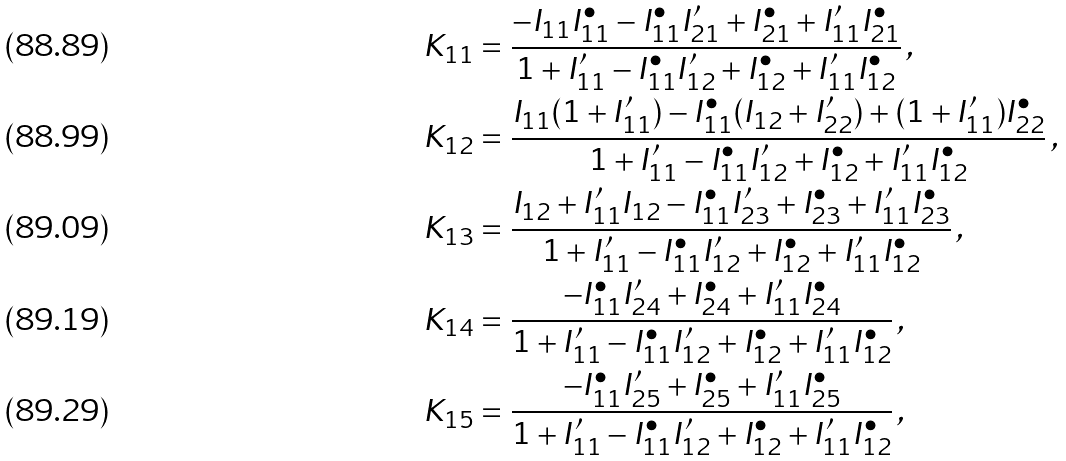Convert formula to latex. <formula><loc_0><loc_0><loc_500><loc_500>K _ { 1 1 } & = \frac { - I _ { 1 1 } I _ { 1 1 } ^ { \bullet } - I _ { 1 1 } ^ { \bullet } I _ { 2 1 } ^ { \prime } + I _ { 2 1 } ^ { \bullet } + I _ { 1 1 } ^ { \prime } I _ { 2 1 } ^ { \bullet } } { 1 + I _ { 1 1 } ^ { \prime } - I _ { 1 1 } ^ { \bullet } I _ { 1 2 } ^ { \prime } + I _ { 1 2 } ^ { \bullet } + I _ { 1 1 } ^ { \prime } I _ { 1 2 } ^ { \bullet } } \, , \\ K _ { 1 2 } & = \frac { I _ { 1 1 } ( 1 + I _ { 1 1 } ^ { \prime } ) - I _ { 1 1 } ^ { \bullet } ( I _ { 1 2 } + I _ { 2 2 } ^ { \prime } ) + ( 1 + I _ { 1 1 } ^ { \prime } ) I _ { 2 2 } ^ { \bullet } } { 1 + I _ { 1 1 } ^ { \prime } - I _ { 1 1 } ^ { \bullet } I _ { 1 2 } ^ { \prime } + I _ { 1 2 } ^ { \bullet } + I _ { 1 1 } ^ { \prime } I _ { 1 2 } ^ { \bullet } } \, , \\ K _ { 1 3 } & = \frac { I _ { 1 2 } + I _ { 1 1 } ^ { \prime } I _ { 1 2 } - I _ { 1 1 } ^ { \bullet } I _ { 2 3 } ^ { \prime } + I _ { 2 3 } ^ { \bullet } + I _ { 1 1 } ^ { \prime } I _ { 2 3 } ^ { \bullet } } { 1 + I _ { 1 1 } ^ { \prime } - I _ { 1 1 } ^ { \bullet } I _ { 1 2 } ^ { \prime } + I _ { 1 2 } ^ { \bullet } + I _ { 1 1 } ^ { \prime } I _ { 1 2 } ^ { \bullet } } \, , \\ K _ { 1 4 } & = \frac { - I _ { 1 1 } ^ { \bullet } I _ { 2 4 } ^ { \prime } + I _ { 2 4 } ^ { \bullet } + I _ { 1 1 } ^ { \prime } I _ { 2 4 } ^ { \bullet } } { 1 + I _ { 1 1 } ^ { \prime } - I _ { 1 1 } ^ { \bullet } I _ { 1 2 } ^ { \prime } + I _ { 1 2 } ^ { \bullet } + I _ { 1 1 } ^ { \prime } I _ { 1 2 } ^ { \bullet } } \, , \\ K _ { 1 5 } & = \frac { - I _ { 1 1 } ^ { \bullet } I _ { 2 5 } ^ { \prime } + I _ { 2 5 } ^ { \bullet } + I _ { 1 1 } ^ { \prime } I _ { 2 5 } ^ { \bullet } } { 1 + I _ { 1 1 } ^ { \prime } - I _ { 1 1 } ^ { \bullet } I _ { 1 2 } ^ { \prime } + I _ { 1 2 } ^ { \bullet } + I _ { 1 1 } ^ { \prime } I _ { 1 2 } ^ { \bullet } } \, ,</formula> 